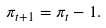Convert formula to latex. <formula><loc_0><loc_0><loc_500><loc_500>\pi _ { t + 1 } = \pi _ { t } - 1 .</formula> 